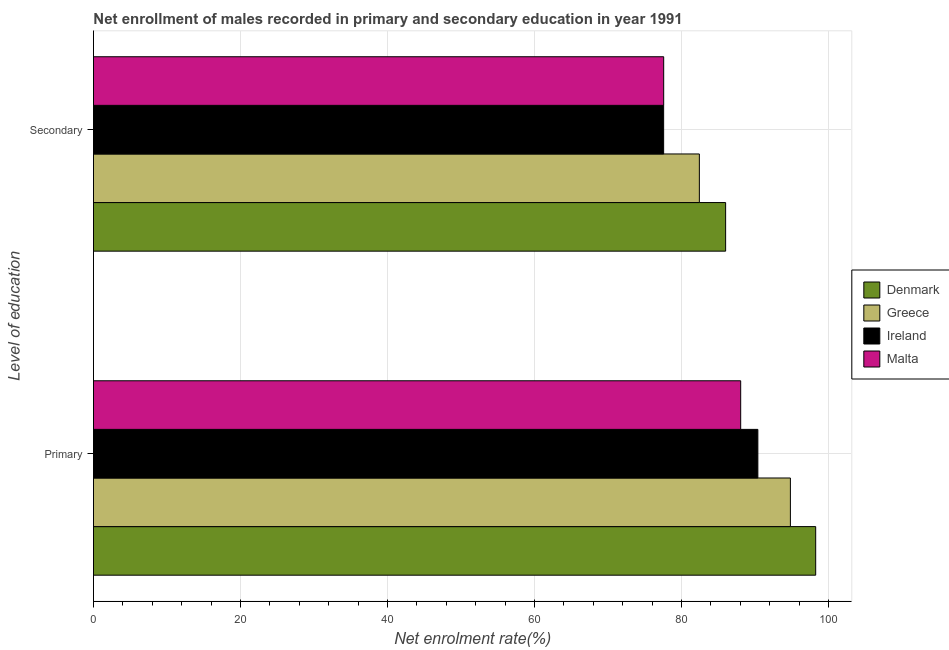How many groups of bars are there?
Your answer should be compact. 2. Are the number of bars per tick equal to the number of legend labels?
Your response must be concise. Yes. Are the number of bars on each tick of the Y-axis equal?
Offer a terse response. Yes. How many bars are there on the 1st tick from the top?
Offer a very short reply. 4. What is the label of the 2nd group of bars from the top?
Ensure brevity in your answer.  Primary. What is the enrollment rate in secondary education in Malta?
Your answer should be compact. 77.57. Across all countries, what is the maximum enrollment rate in primary education?
Keep it short and to the point. 98.25. Across all countries, what is the minimum enrollment rate in secondary education?
Provide a succinct answer. 77.57. In which country was the enrollment rate in primary education minimum?
Offer a very short reply. Malta. What is the total enrollment rate in primary education in the graph?
Provide a short and direct response. 371.49. What is the difference between the enrollment rate in primary education in Malta and that in Denmark?
Provide a succinct answer. -10.2. What is the difference between the enrollment rate in primary education in Denmark and the enrollment rate in secondary education in Ireland?
Give a very brief answer. 20.69. What is the average enrollment rate in secondary education per country?
Your answer should be very brief. 80.89. What is the difference between the enrollment rate in secondary education and enrollment rate in primary education in Ireland?
Ensure brevity in your answer.  -12.82. What is the ratio of the enrollment rate in secondary education in Denmark to that in Ireland?
Give a very brief answer. 1.11. In how many countries, is the enrollment rate in primary education greater than the average enrollment rate in primary education taken over all countries?
Keep it short and to the point. 2. What does the 3rd bar from the top in Primary represents?
Provide a short and direct response. Greece. What does the 2nd bar from the bottom in Secondary represents?
Give a very brief answer. Greece. Are all the bars in the graph horizontal?
Provide a succinct answer. Yes. What is the difference between two consecutive major ticks on the X-axis?
Provide a short and direct response. 20. Does the graph contain any zero values?
Your answer should be compact. No. Does the graph contain grids?
Your response must be concise. Yes. Where does the legend appear in the graph?
Give a very brief answer. Center right. How are the legend labels stacked?
Your answer should be compact. Vertical. What is the title of the graph?
Provide a succinct answer. Net enrollment of males recorded in primary and secondary education in year 1991. What is the label or title of the X-axis?
Your answer should be very brief. Net enrolment rate(%). What is the label or title of the Y-axis?
Provide a short and direct response. Level of education. What is the Net enrolment rate(%) of Denmark in Primary?
Your answer should be compact. 98.25. What is the Net enrolment rate(%) of Greece in Primary?
Offer a terse response. 94.81. What is the Net enrolment rate(%) in Ireland in Primary?
Keep it short and to the point. 90.38. What is the Net enrolment rate(%) of Malta in Primary?
Ensure brevity in your answer.  88.05. What is the Net enrolment rate(%) in Denmark in Secondary?
Ensure brevity in your answer.  86. What is the Net enrolment rate(%) in Greece in Secondary?
Offer a very short reply. 82.43. What is the Net enrolment rate(%) of Ireland in Secondary?
Your answer should be compact. 77.57. What is the Net enrolment rate(%) of Malta in Secondary?
Provide a succinct answer. 77.57. Across all Level of education, what is the maximum Net enrolment rate(%) of Denmark?
Ensure brevity in your answer.  98.25. Across all Level of education, what is the maximum Net enrolment rate(%) in Greece?
Give a very brief answer. 94.81. Across all Level of education, what is the maximum Net enrolment rate(%) of Ireland?
Your answer should be very brief. 90.38. Across all Level of education, what is the maximum Net enrolment rate(%) of Malta?
Offer a very short reply. 88.05. Across all Level of education, what is the minimum Net enrolment rate(%) in Denmark?
Make the answer very short. 86. Across all Level of education, what is the minimum Net enrolment rate(%) in Greece?
Provide a succinct answer. 82.43. Across all Level of education, what is the minimum Net enrolment rate(%) of Ireland?
Make the answer very short. 77.57. Across all Level of education, what is the minimum Net enrolment rate(%) in Malta?
Give a very brief answer. 77.57. What is the total Net enrolment rate(%) in Denmark in the graph?
Your response must be concise. 184.25. What is the total Net enrolment rate(%) of Greece in the graph?
Your answer should be compact. 177.23. What is the total Net enrolment rate(%) of Ireland in the graph?
Ensure brevity in your answer.  167.95. What is the total Net enrolment rate(%) of Malta in the graph?
Keep it short and to the point. 165.62. What is the difference between the Net enrolment rate(%) in Denmark in Primary and that in Secondary?
Your answer should be very brief. 12.25. What is the difference between the Net enrolment rate(%) of Greece in Primary and that in Secondary?
Keep it short and to the point. 12.38. What is the difference between the Net enrolment rate(%) in Ireland in Primary and that in Secondary?
Your response must be concise. 12.82. What is the difference between the Net enrolment rate(%) of Malta in Primary and that in Secondary?
Keep it short and to the point. 10.47. What is the difference between the Net enrolment rate(%) in Denmark in Primary and the Net enrolment rate(%) in Greece in Secondary?
Give a very brief answer. 15.83. What is the difference between the Net enrolment rate(%) in Denmark in Primary and the Net enrolment rate(%) in Ireland in Secondary?
Offer a very short reply. 20.69. What is the difference between the Net enrolment rate(%) in Denmark in Primary and the Net enrolment rate(%) in Malta in Secondary?
Make the answer very short. 20.68. What is the difference between the Net enrolment rate(%) in Greece in Primary and the Net enrolment rate(%) in Ireland in Secondary?
Your answer should be very brief. 17.24. What is the difference between the Net enrolment rate(%) in Greece in Primary and the Net enrolment rate(%) in Malta in Secondary?
Your response must be concise. 17.24. What is the difference between the Net enrolment rate(%) in Ireland in Primary and the Net enrolment rate(%) in Malta in Secondary?
Your response must be concise. 12.81. What is the average Net enrolment rate(%) in Denmark per Level of education?
Keep it short and to the point. 92.12. What is the average Net enrolment rate(%) in Greece per Level of education?
Ensure brevity in your answer.  88.62. What is the average Net enrolment rate(%) in Ireland per Level of education?
Your answer should be compact. 83.97. What is the average Net enrolment rate(%) in Malta per Level of education?
Ensure brevity in your answer.  82.81. What is the difference between the Net enrolment rate(%) of Denmark and Net enrolment rate(%) of Greece in Primary?
Provide a succinct answer. 3.44. What is the difference between the Net enrolment rate(%) in Denmark and Net enrolment rate(%) in Ireland in Primary?
Your response must be concise. 7.87. What is the difference between the Net enrolment rate(%) in Denmark and Net enrolment rate(%) in Malta in Primary?
Your response must be concise. 10.2. What is the difference between the Net enrolment rate(%) of Greece and Net enrolment rate(%) of Ireland in Primary?
Your answer should be very brief. 4.43. What is the difference between the Net enrolment rate(%) of Greece and Net enrolment rate(%) of Malta in Primary?
Provide a succinct answer. 6.76. What is the difference between the Net enrolment rate(%) in Ireland and Net enrolment rate(%) in Malta in Primary?
Your answer should be compact. 2.34. What is the difference between the Net enrolment rate(%) in Denmark and Net enrolment rate(%) in Greece in Secondary?
Ensure brevity in your answer.  3.57. What is the difference between the Net enrolment rate(%) in Denmark and Net enrolment rate(%) in Ireland in Secondary?
Make the answer very short. 8.43. What is the difference between the Net enrolment rate(%) in Denmark and Net enrolment rate(%) in Malta in Secondary?
Ensure brevity in your answer.  8.42. What is the difference between the Net enrolment rate(%) of Greece and Net enrolment rate(%) of Ireland in Secondary?
Provide a succinct answer. 4.86. What is the difference between the Net enrolment rate(%) in Greece and Net enrolment rate(%) in Malta in Secondary?
Keep it short and to the point. 4.85. What is the difference between the Net enrolment rate(%) in Ireland and Net enrolment rate(%) in Malta in Secondary?
Give a very brief answer. -0.01. What is the ratio of the Net enrolment rate(%) of Denmark in Primary to that in Secondary?
Provide a succinct answer. 1.14. What is the ratio of the Net enrolment rate(%) of Greece in Primary to that in Secondary?
Ensure brevity in your answer.  1.15. What is the ratio of the Net enrolment rate(%) of Ireland in Primary to that in Secondary?
Make the answer very short. 1.17. What is the ratio of the Net enrolment rate(%) of Malta in Primary to that in Secondary?
Provide a succinct answer. 1.14. What is the difference between the highest and the second highest Net enrolment rate(%) of Denmark?
Your answer should be very brief. 12.25. What is the difference between the highest and the second highest Net enrolment rate(%) of Greece?
Offer a terse response. 12.38. What is the difference between the highest and the second highest Net enrolment rate(%) in Ireland?
Your response must be concise. 12.82. What is the difference between the highest and the second highest Net enrolment rate(%) of Malta?
Your response must be concise. 10.47. What is the difference between the highest and the lowest Net enrolment rate(%) of Denmark?
Provide a succinct answer. 12.25. What is the difference between the highest and the lowest Net enrolment rate(%) in Greece?
Offer a very short reply. 12.38. What is the difference between the highest and the lowest Net enrolment rate(%) of Ireland?
Make the answer very short. 12.82. What is the difference between the highest and the lowest Net enrolment rate(%) in Malta?
Make the answer very short. 10.47. 